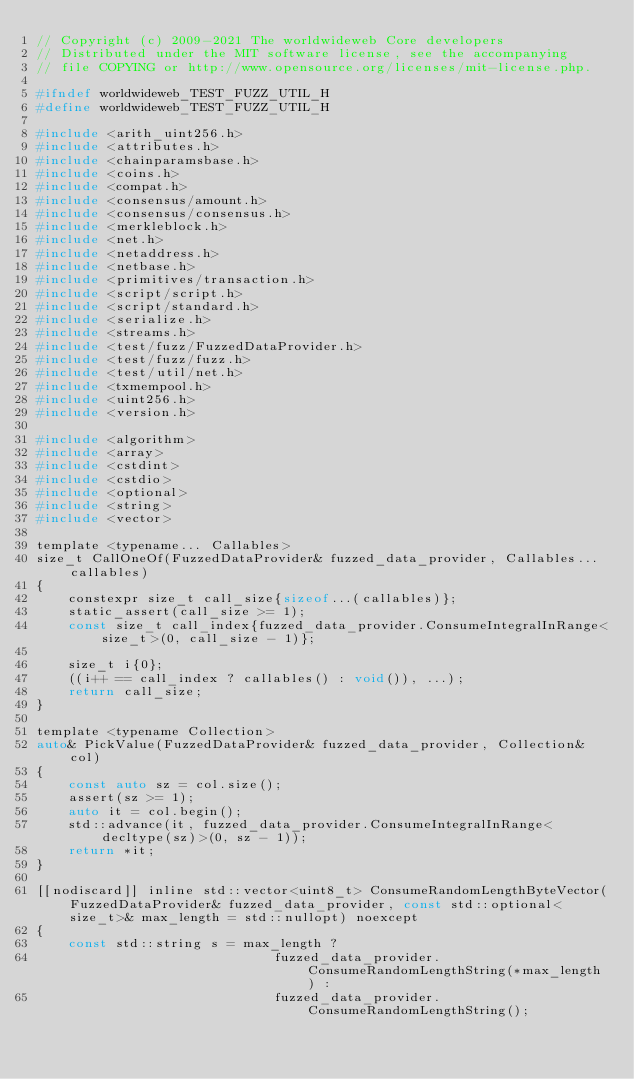<code> <loc_0><loc_0><loc_500><loc_500><_C_>// Copyright (c) 2009-2021 The worldwideweb Core developers
// Distributed under the MIT software license, see the accompanying
// file COPYING or http://www.opensource.org/licenses/mit-license.php.

#ifndef worldwideweb_TEST_FUZZ_UTIL_H
#define worldwideweb_TEST_FUZZ_UTIL_H

#include <arith_uint256.h>
#include <attributes.h>
#include <chainparamsbase.h>
#include <coins.h>
#include <compat.h>
#include <consensus/amount.h>
#include <consensus/consensus.h>
#include <merkleblock.h>
#include <net.h>
#include <netaddress.h>
#include <netbase.h>
#include <primitives/transaction.h>
#include <script/script.h>
#include <script/standard.h>
#include <serialize.h>
#include <streams.h>
#include <test/fuzz/FuzzedDataProvider.h>
#include <test/fuzz/fuzz.h>
#include <test/util/net.h>
#include <txmempool.h>
#include <uint256.h>
#include <version.h>

#include <algorithm>
#include <array>
#include <cstdint>
#include <cstdio>
#include <optional>
#include <string>
#include <vector>

template <typename... Callables>
size_t CallOneOf(FuzzedDataProvider& fuzzed_data_provider, Callables... callables)
{
    constexpr size_t call_size{sizeof...(callables)};
    static_assert(call_size >= 1);
    const size_t call_index{fuzzed_data_provider.ConsumeIntegralInRange<size_t>(0, call_size - 1)};

    size_t i{0};
    ((i++ == call_index ? callables() : void()), ...);
    return call_size;
}

template <typename Collection>
auto& PickValue(FuzzedDataProvider& fuzzed_data_provider, Collection& col)
{
    const auto sz = col.size();
    assert(sz >= 1);
    auto it = col.begin();
    std::advance(it, fuzzed_data_provider.ConsumeIntegralInRange<decltype(sz)>(0, sz - 1));
    return *it;
}

[[nodiscard]] inline std::vector<uint8_t> ConsumeRandomLengthByteVector(FuzzedDataProvider& fuzzed_data_provider, const std::optional<size_t>& max_length = std::nullopt) noexcept
{
    const std::string s = max_length ?
                              fuzzed_data_provider.ConsumeRandomLengthString(*max_length) :
                              fuzzed_data_provider.ConsumeRandomLengthString();</code> 